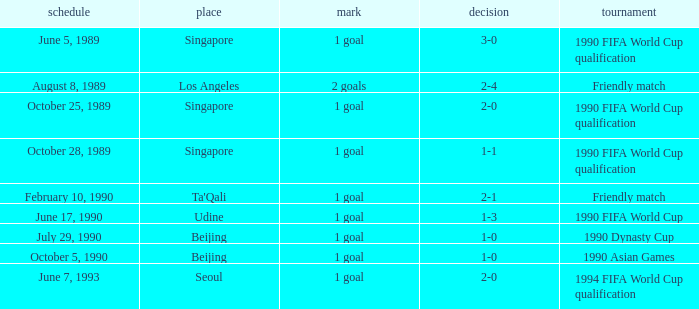What is the score of the match on October 5, 1990? 1 goal. 